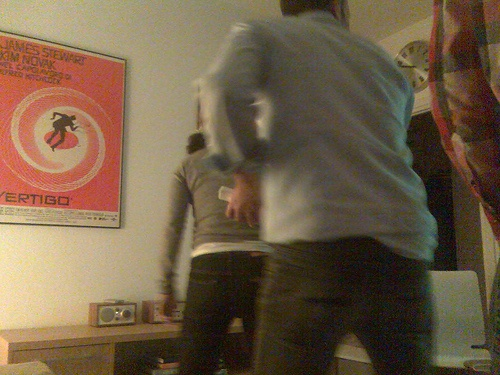Describe the objects in this image and their specific colors. I can see people in tan, black, gray, and darkgreen tones, people in tan, black, gray, and olive tones, people in tan, maroon, black, olive, and brown tones, chair in tan, gray, olive, and black tones, and clock in tan, olive, and gray tones in this image. 